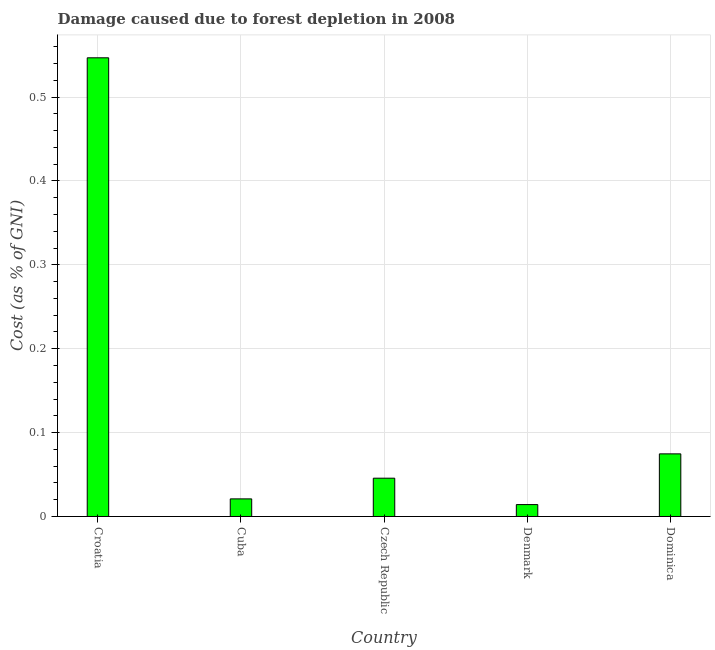Does the graph contain grids?
Offer a very short reply. Yes. What is the title of the graph?
Your response must be concise. Damage caused due to forest depletion in 2008. What is the label or title of the X-axis?
Make the answer very short. Country. What is the label or title of the Y-axis?
Make the answer very short. Cost (as % of GNI). What is the damage caused due to forest depletion in Cuba?
Offer a terse response. 0.02. Across all countries, what is the maximum damage caused due to forest depletion?
Provide a short and direct response. 0.55. Across all countries, what is the minimum damage caused due to forest depletion?
Ensure brevity in your answer.  0.01. In which country was the damage caused due to forest depletion maximum?
Your response must be concise. Croatia. In which country was the damage caused due to forest depletion minimum?
Offer a very short reply. Denmark. What is the sum of the damage caused due to forest depletion?
Your answer should be compact. 0.7. What is the difference between the damage caused due to forest depletion in Croatia and Denmark?
Give a very brief answer. 0.53. What is the average damage caused due to forest depletion per country?
Provide a succinct answer. 0.14. What is the median damage caused due to forest depletion?
Keep it short and to the point. 0.05. In how many countries, is the damage caused due to forest depletion greater than 0.14 %?
Keep it short and to the point. 1. What is the ratio of the damage caused due to forest depletion in Croatia to that in Denmark?
Provide a succinct answer. 38.57. Is the difference between the damage caused due to forest depletion in Croatia and Denmark greater than the difference between any two countries?
Give a very brief answer. Yes. What is the difference between the highest and the second highest damage caused due to forest depletion?
Offer a terse response. 0.47. Is the sum of the damage caused due to forest depletion in Croatia and Denmark greater than the maximum damage caused due to forest depletion across all countries?
Your answer should be very brief. Yes. What is the difference between the highest and the lowest damage caused due to forest depletion?
Your response must be concise. 0.53. How many bars are there?
Your answer should be compact. 5. What is the Cost (as % of GNI) of Croatia?
Your response must be concise. 0.55. What is the Cost (as % of GNI) of Cuba?
Your response must be concise. 0.02. What is the Cost (as % of GNI) in Czech Republic?
Your answer should be very brief. 0.05. What is the Cost (as % of GNI) of Denmark?
Your response must be concise. 0.01. What is the Cost (as % of GNI) in Dominica?
Provide a short and direct response. 0.07. What is the difference between the Cost (as % of GNI) in Croatia and Cuba?
Offer a terse response. 0.53. What is the difference between the Cost (as % of GNI) in Croatia and Czech Republic?
Make the answer very short. 0.5. What is the difference between the Cost (as % of GNI) in Croatia and Denmark?
Keep it short and to the point. 0.53. What is the difference between the Cost (as % of GNI) in Croatia and Dominica?
Give a very brief answer. 0.47. What is the difference between the Cost (as % of GNI) in Cuba and Czech Republic?
Keep it short and to the point. -0.02. What is the difference between the Cost (as % of GNI) in Cuba and Denmark?
Provide a succinct answer. 0.01. What is the difference between the Cost (as % of GNI) in Cuba and Dominica?
Offer a terse response. -0.05. What is the difference between the Cost (as % of GNI) in Czech Republic and Denmark?
Offer a terse response. 0.03. What is the difference between the Cost (as % of GNI) in Czech Republic and Dominica?
Give a very brief answer. -0.03. What is the difference between the Cost (as % of GNI) in Denmark and Dominica?
Give a very brief answer. -0.06. What is the ratio of the Cost (as % of GNI) in Croatia to that in Cuba?
Give a very brief answer. 26.06. What is the ratio of the Cost (as % of GNI) in Croatia to that in Czech Republic?
Offer a very short reply. 11.98. What is the ratio of the Cost (as % of GNI) in Croatia to that in Denmark?
Ensure brevity in your answer.  38.57. What is the ratio of the Cost (as % of GNI) in Croatia to that in Dominica?
Your answer should be compact. 7.33. What is the ratio of the Cost (as % of GNI) in Cuba to that in Czech Republic?
Your answer should be very brief. 0.46. What is the ratio of the Cost (as % of GNI) in Cuba to that in Denmark?
Ensure brevity in your answer.  1.48. What is the ratio of the Cost (as % of GNI) in Cuba to that in Dominica?
Give a very brief answer. 0.28. What is the ratio of the Cost (as % of GNI) in Czech Republic to that in Denmark?
Provide a succinct answer. 3.22. What is the ratio of the Cost (as % of GNI) in Czech Republic to that in Dominica?
Your response must be concise. 0.61. What is the ratio of the Cost (as % of GNI) in Denmark to that in Dominica?
Offer a terse response. 0.19. 